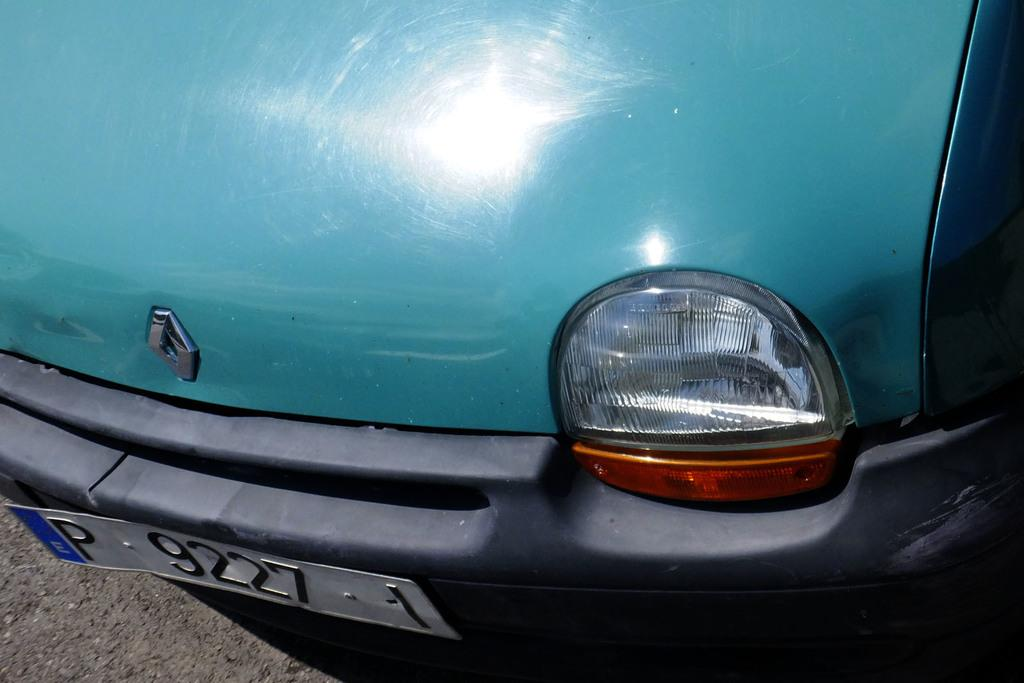What is the main subject of the image? The main subject of the image is a car. Can you describe any specific features of the car? The car has a number plate. What type of hot food is being served in the car's trunk? There is no indication of any food, hot or otherwise, in the image. The image only shows a car with a number plate. 